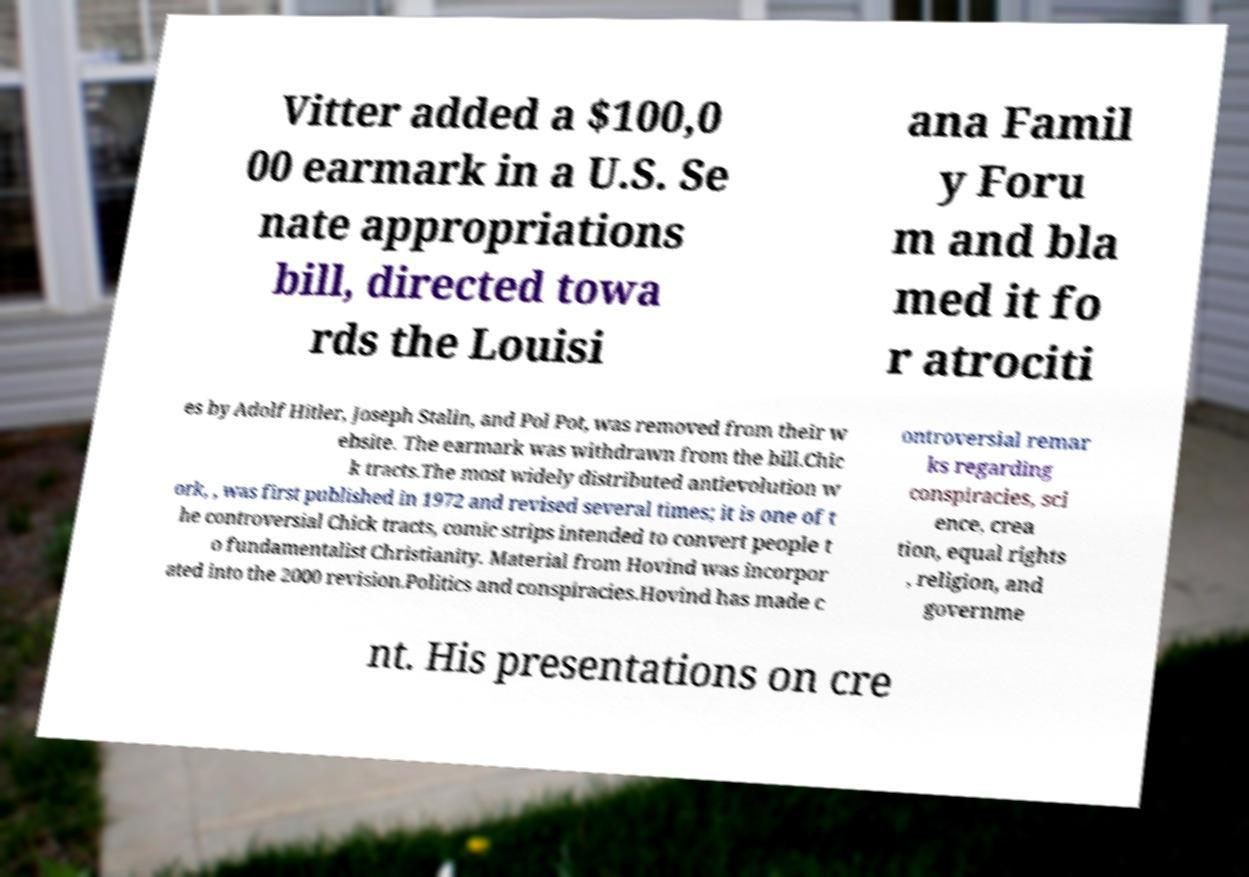Can you accurately transcribe the text from the provided image for me? Vitter added a $100,0 00 earmark in a U.S. Se nate appropriations bill, directed towa rds the Louisi ana Famil y Foru m and bla med it fo r atrociti es by Adolf Hitler, Joseph Stalin, and Pol Pot, was removed from their w ebsite. The earmark was withdrawn from the bill.Chic k tracts.The most widely distributed antievolution w ork, , was first published in 1972 and revised several times; it is one of t he controversial Chick tracts, comic strips intended to convert people t o fundamentalist Christianity. Material from Hovind was incorpor ated into the 2000 revision.Politics and conspiracies.Hovind has made c ontroversial remar ks regarding conspiracies, sci ence, crea tion, equal rights , religion, and governme nt. His presentations on cre 